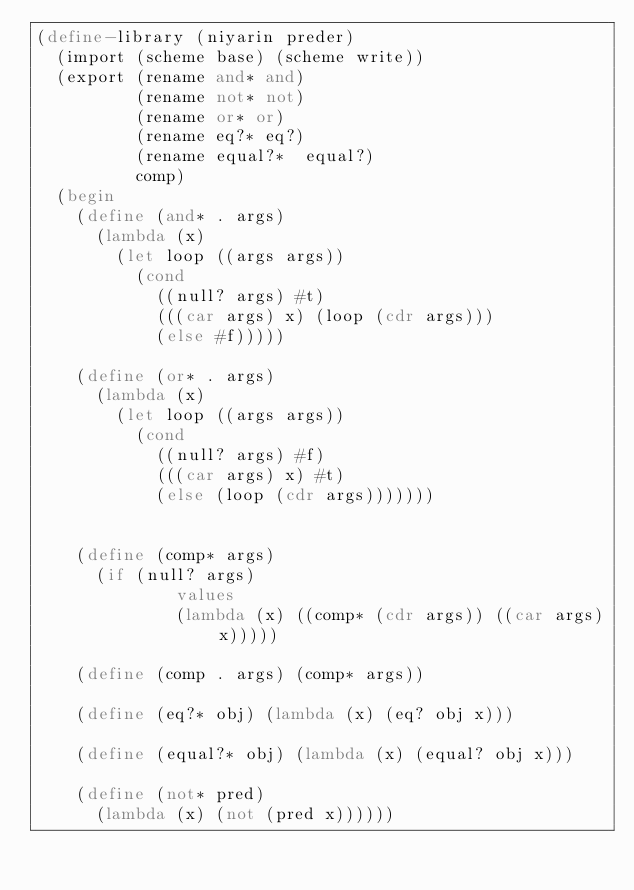<code> <loc_0><loc_0><loc_500><loc_500><_Scheme_>(define-library (niyarin preder)
  (import (scheme base) (scheme write))
  (export (rename and* and)
          (rename not* not)
          (rename or* or)
          (rename eq?* eq?)
          (rename equal?*  equal?)
          comp)
  (begin
    (define (and* . args)
      (lambda (x)
        (let loop ((args args))
          (cond
            ((null? args) #t)
            (((car args) x) (loop (cdr args)))
            (else #f)))))

    (define (or* . args)
      (lambda (x)
        (let loop ((args args))
          (cond
            ((null? args) #f)
            (((car args) x) #t)
            (else (loop (cdr args)))))))


    (define (comp* args)
      (if (null? args)
              values
              (lambda (x) ((comp* (cdr args)) ((car args) x)))))

    (define (comp . args) (comp* args))

    (define (eq?* obj) (lambda (x) (eq? obj x)))

    (define (equal?* obj) (lambda (x) (equal? obj x)))

    (define (not* pred)
      (lambda (x) (not (pred x))))))
</code> 